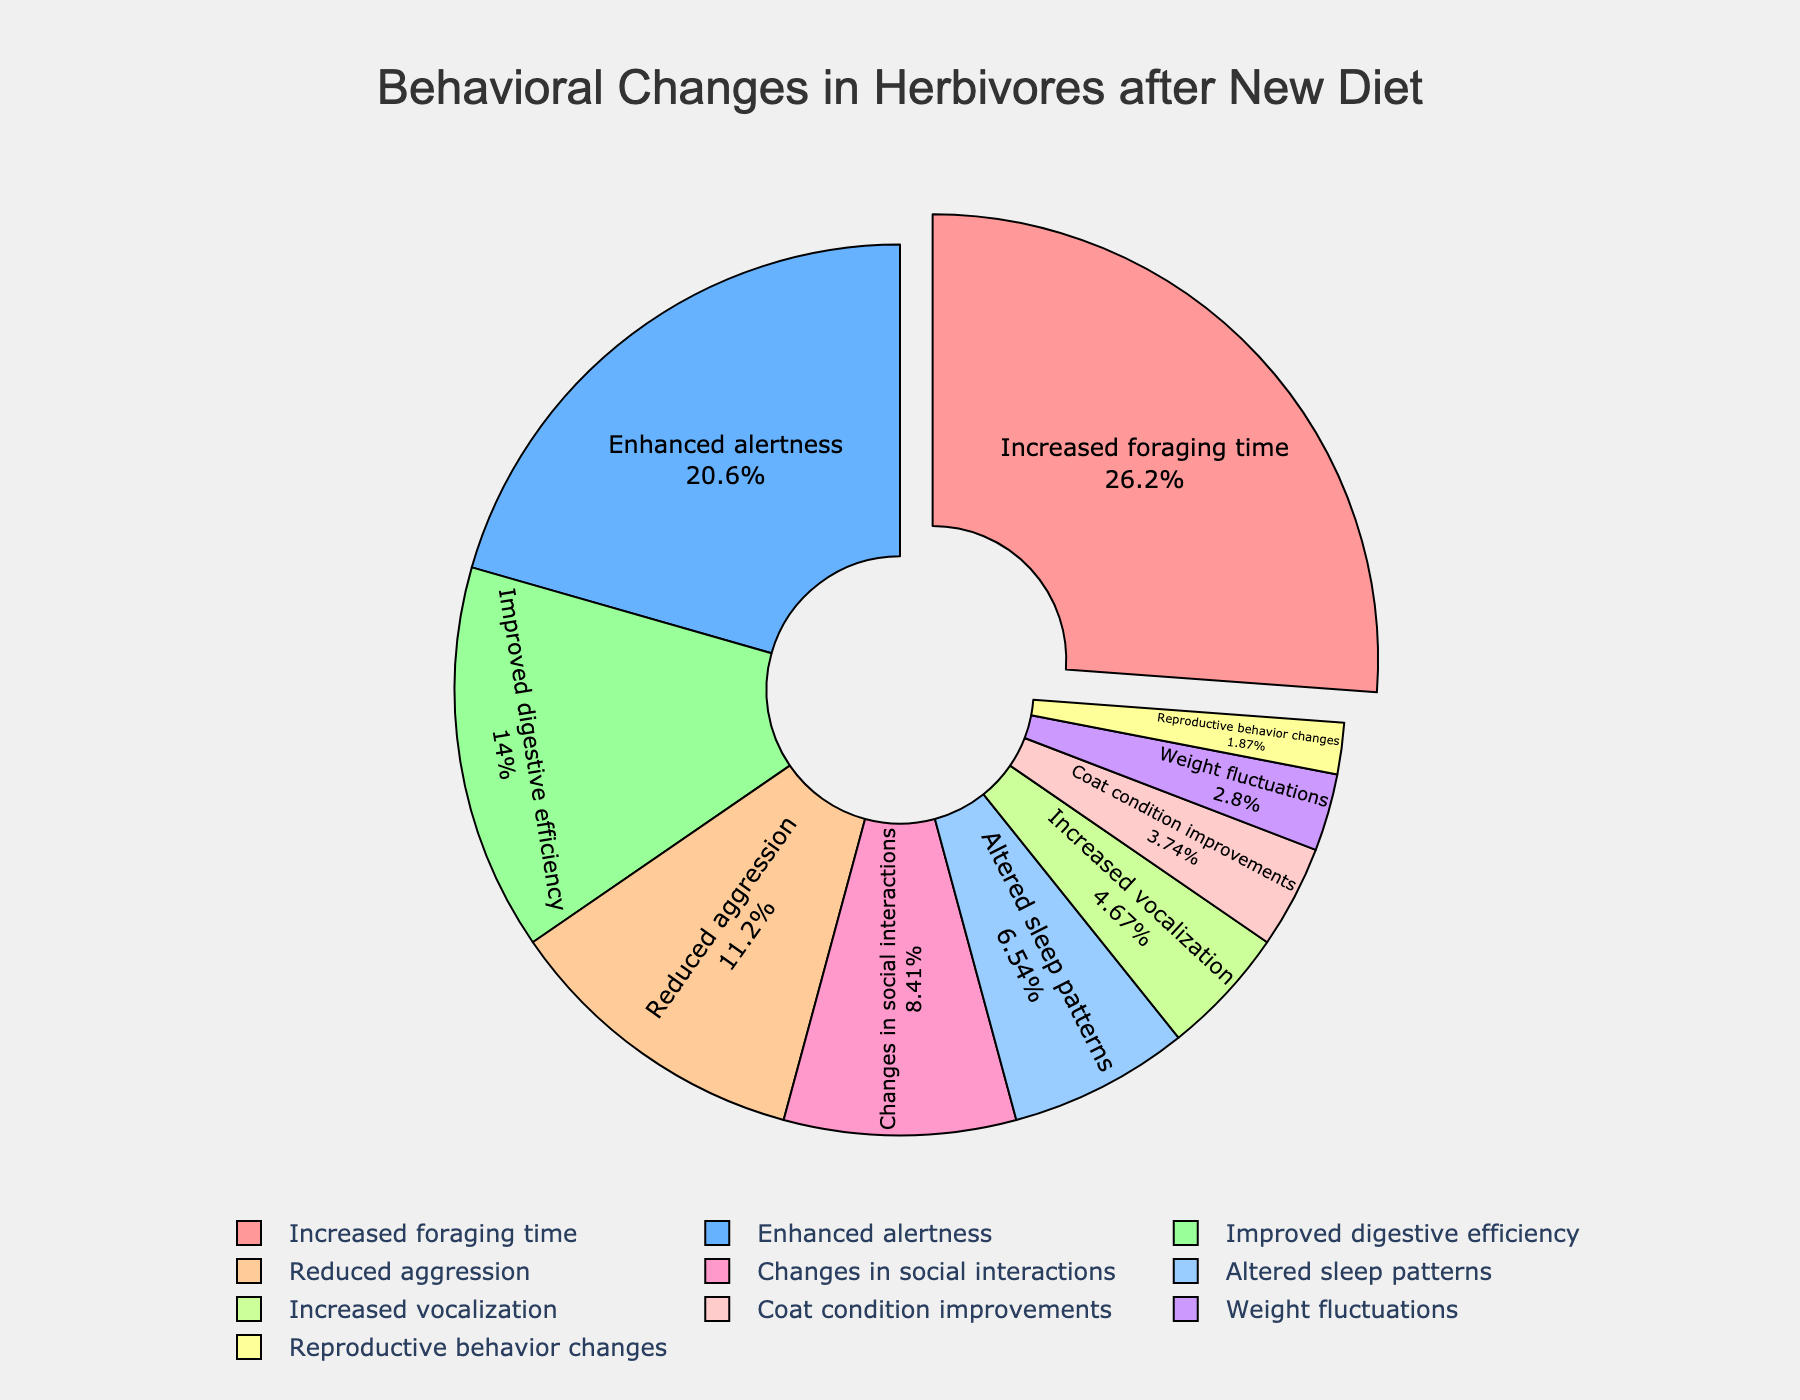What percentage of herbivores showed enhanced alertness after the new diet was introduced? The figure shows the breakdown of behavioral changes with associated percentages. Find "Enhanced alertness" and read the percentage value.
Answer: 22% How much higher is the percentage of herbivores with increased foraging time compared to those with improved digestive efficiency? Locate the percentages for "Increased foraging time" (28%) and "Improved digestive efficiency" (15%). Subtract the latter from the former: 28% - 15% = 13%.
Answer: 13% What are the two least common behavioral changes observed? Identify the segments with the smallest percentages, which are 2% and 3%. These correspond to "Reproductive behavior changes" and "Weight fluctuations".
Answer: Reproductive behavior changes and Weight fluctuations What is the combined percentage of herbivores that exhibited reduced aggression and changes in social interactions? Find the percentages for "Reduced aggression" (12%) and "Changes in social interactions" (9%). Add them together: 12% + 9% = 21%.
Answer: 21% Which segment was pulled out in the pie chart? Examine the segments in the pie chart. The pulled-out segment represents "Increased foraging time", as it draws attention for being the largest percentage (28%).
Answer: Increased foraging time Which behavior change has a lower percentage: Altered sleep patterns or Increased vocalization? Compare the percentages for "Altered sleep patterns" (7%) and "Increased vocalization" (5%). "Increased vocalization" has a lower percentage.
Answer: Increased vocalization What's the total percentage for the three behavior changes with the highest values? Identify the three highest percentages: 28% (Increased foraging time), 22% (Enhanced alertness), and 15% (Improved digestive efficiency). Sum them: 28% + 22% + 15% = 65%.
Answer: 65% How does the percentage for improved digestive efficiency compare to the percentage for reduced aggression? Compare 15% for "Improved digestive efficiency" with 12% for "Reduced aggression". "Improved digestive efficiency" is higher.
Answer: Improved digestive efficiency is higher 